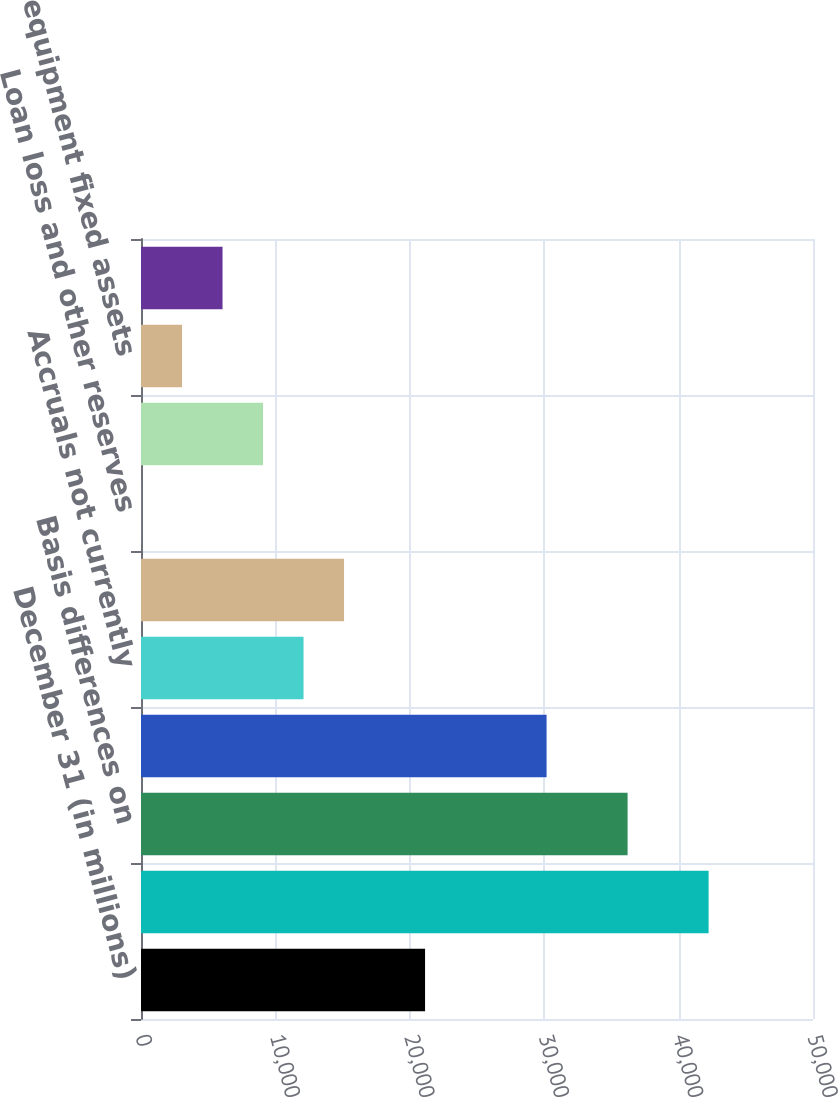<chart> <loc_0><loc_0><loc_500><loc_500><bar_chart><fcel>December 31 (in millions)<fcel>Losses and tax credit<fcel>Basis differences on<fcel>Life policy reserves<fcel>Accruals not currently<fcel>Loss reserve discount<fcel>Loan loss and other reserves<fcel>Unearned premium reserve<fcel>Flight equipment fixed assets<fcel>Other<nl><fcel>21135.6<fcel>42232.2<fcel>36204.6<fcel>30177<fcel>12094.2<fcel>15108<fcel>39<fcel>9080.4<fcel>3052.8<fcel>6066.6<nl></chart> 